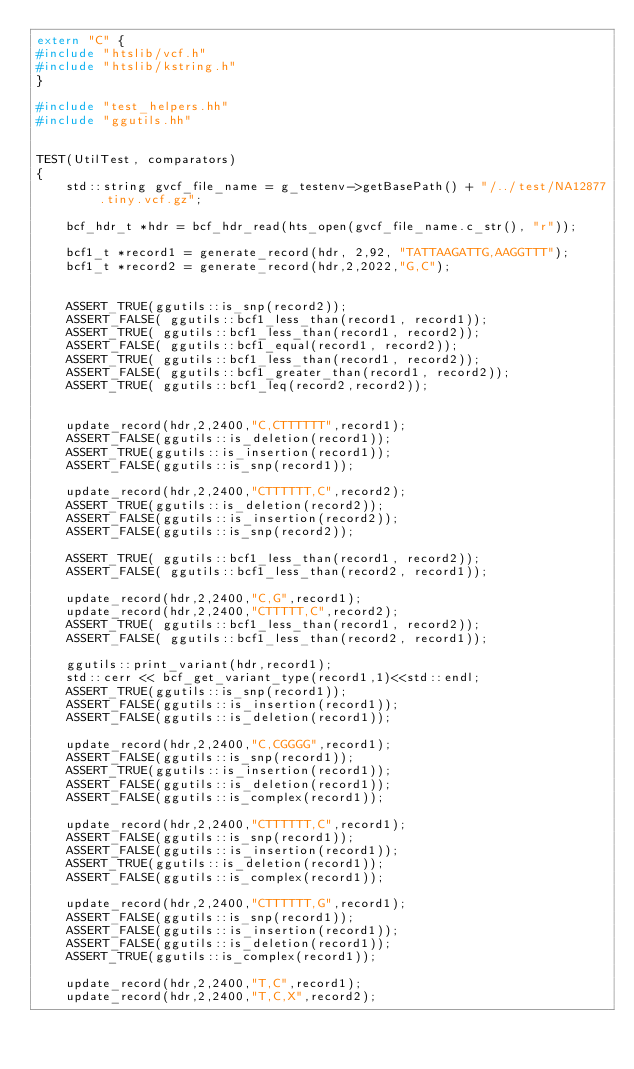<code> <loc_0><loc_0><loc_500><loc_500><_C++_>extern "C" {
#include "htslib/vcf.h"
#include "htslib/kstring.h"
}

#include "test_helpers.hh"
#include "ggutils.hh"


TEST(UtilTest, comparators)
{
    std::string gvcf_file_name = g_testenv->getBasePath() + "/../test/NA12877.tiny.vcf.gz";

    bcf_hdr_t *hdr = bcf_hdr_read(hts_open(gvcf_file_name.c_str(), "r"));

    bcf1_t *record1 = generate_record(hdr, 2,92, "TATTAAGATTG,AAGGTTT");
    bcf1_t *record2 = generate_record(hdr,2,2022,"G,C");


    ASSERT_TRUE(ggutils::is_snp(record2));
    ASSERT_FALSE( ggutils::bcf1_less_than(record1, record1));
    ASSERT_TRUE( ggutils::bcf1_less_than(record1, record2));
    ASSERT_FALSE( ggutils::bcf1_equal(record1, record2));
    ASSERT_TRUE( ggutils::bcf1_less_than(record1, record2));
    ASSERT_FALSE( ggutils::bcf1_greater_than(record1, record2));
    ASSERT_TRUE( ggutils::bcf1_leq(record2,record2));


    update_record(hdr,2,2400,"C,CTTTTTT",record1);
    ASSERT_FALSE(ggutils::is_deletion(record1));
    ASSERT_TRUE(ggutils::is_insertion(record1));
    ASSERT_FALSE(ggutils::is_snp(record1));

    update_record(hdr,2,2400,"CTTTTTT,C",record2);
    ASSERT_TRUE(ggutils::is_deletion(record2));
    ASSERT_FALSE(ggutils::is_insertion(record2));
    ASSERT_FALSE(ggutils::is_snp(record2));

    ASSERT_TRUE( ggutils::bcf1_less_than(record1, record2));
    ASSERT_FALSE( ggutils::bcf1_less_than(record2, record1));

    update_record(hdr,2,2400,"C,G",record1);
    update_record(hdr,2,2400,"CTTTTT,C",record2);
    ASSERT_TRUE( ggutils::bcf1_less_than(record1, record2));
    ASSERT_FALSE( ggutils::bcf1_less_than(record2, record1));

    ggutils::print_variant(hdr,record1);
    std::cerr << bcf_get_variant_type(record1,1)<<std::endl;
    ASSERT_TRUE(ggutils::is_snp(record1));
    ASSERT_FALSE(ggutils::is_insertion(record1));
    ASSERT_FALSE(ggutils::is_deletion(record1));

    update_record(hdr,2,2400,"C,CGGGG",record1);
    ASSERT_FALSE(ggutils::is_snp(record1));
    ASSERT_TRUE(ggutils::is_insertion(record1));
    ASSERT_FALSE(ggutils::is_deletion(record1));
    ASSERT_FALSE(ggutils::is_complex(record1));

    update_record(hdr,2,2400,"CTTTTTT,C",record1);
    ASSERT_FALSE(ggutils::is_snp(record1));
    ASSERT_FALSE(ggutils::is_insertion(record1));
    ASSERT_TRUE(ggutils::is_deletion(record1));
    ASSERT_FALSE(ggutils::is_complex(record1));

    update_record(hdr,2,2400,"CTTTTTT,G",record1);
    ASSERT_FALSE(ggutils::is_snp(record1));
    ASSERT_FALSE(ggutils::is_insertion(record1));
    ASSERT_FALSE(ggutils::is_deletion(record1));
    ASSERT_TRUE(ggutils::is_complex(record1));

    update_record(hdr,2,2400,"T,C",record1);
    update_record(hdr,2,2400,"T,C,X",record2);</code> 